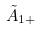Convert formula to latex. <formula><loc_0><loc_0><loc_500><loc_500>\tilde { A } _ { 1 + }</formula> 